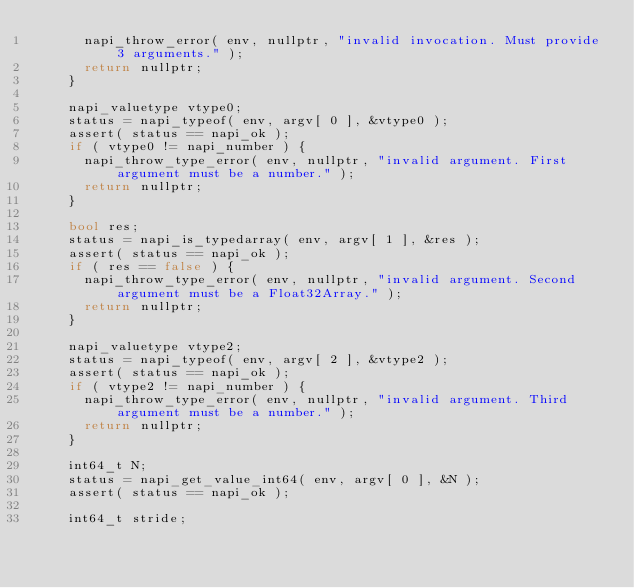<code> <loc_0><loc_0><loc_500><loc_500><_C++_>			napi_throw_error( env, nullptr, "invalid invocation. Must provide 3 arguments." );
			return nullptr;
		}

		napi_valuetype vtype0;
		status = napi_typeof( env, argv[ 0 ], &vtype0 );
		assert( status == napi_ok );
		if ( vtype0 != napi_number ) {
			napi_throw_type_error( env, nullptr, "invalid argument. First argument must be a number." );
			return nullptr;
		}

		bool res;
		status = napi_is_typedarray( env, argv[ 1 ], &res );
		assert( status == napi_ok );
		if ( res == false ) {
			napi_throw_type_error( env, nullptr, "invalid argument. Second argument must be a Float32Array." );
			return nullptr;
		}

		napi_valuetype vtype2;
		status = napi_typeof( env, argv[ 2 ], &vtype2 );
		assert( status == napi_ok );
		if ( vtype2 != napi_number ) {
			napi_throw_type_error( env, nullptr, "invalid argument. Third argument must be a number." );
			return nullptr;
		}

		int64_t N;
		status = napi_get_value_int64( env, argv[ 0 ], &N );
		assert( status == napi_ok );

		int64_t stride;</code> 